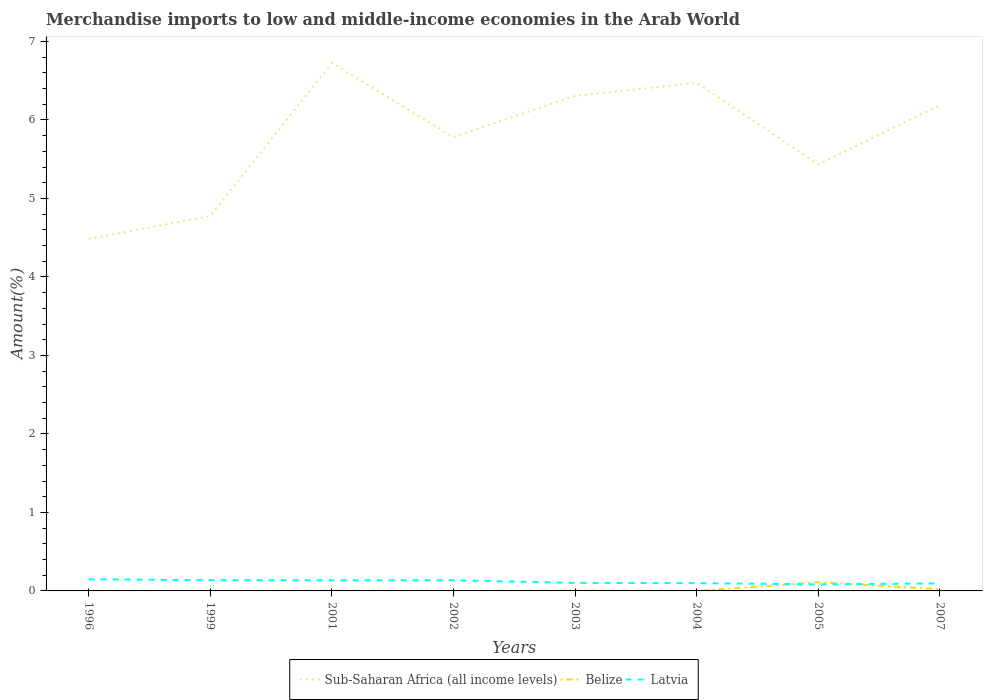How many different coloured lines are there?
Provide a short and direct response. 3. Does the line corresponding to Belize intersect with the line corresponding to Sub-Saharan Africa (all income levels)?
Ensure brevity in your answer.  No. Across all years, what is the maximum percentage of amount earned from merchandise imports in Sub-Saharan Africa (all income levels)?
Offer a very short reply. 4.48. What is the total percentage of amount earned from merchandise imports in Latvia in the graph?
Offer a very short reply. 0.02. What is the difference between the highest and the second highest percentage of amount earned from merchandise imports in Sub-Saharan Africa (all income levels)?
Keep it short and to the point. 2.24. What is the difference between the highest and the lowest percentage of amount earned from merchandise imports in Latvia?
Keep it short and to the point. 4. Is the percentage of amount earned from merchandise imports in Sub-Saharan Africa (all income levels) strictly greater than the percentage of amount earned from merchandise imports in Latvia over the years?
Your answer should be compact. No. What is the difference between two consecutive major ticks on the Y-axis?
Keep it short and to the point. 1. Are the values on the major ticks of Y-axis written in scientific E-notation?
Make the answer very short. No. Does the graph contain grids?
Make the answer very short. No. How many legend labels are there?
Offer a terse response. 3. What is the title of the graph?
Provide a succinct answer. Merchandise imports to low and middle-income economies in the Arab World. What is the label or title of the X-axis?
Give a very brief answer. Years. What is the label or title of the Y-axis?
Your response must be concise. Amount(%). What is the Amount(%) in Sub-Saharan Africa (all income levels) in 1996?
Ensure brevity in your answer.  4.48. What is the Amount(%) in Belize in 1996?
Provide a succinct answer. 0. What is the Amount(%) in Latvia in 1996?
Keep it short and to the point. 0.15. What is the Amount(%) of Sub-Saharan Africa (all income levels) in 1999?
Give a very brief answer. 4.78. What is the Amount(%) of Belize in 1999?
Ensure brevity in your answer.  0. What is the Amount(%) in Latvia in 1999?
Give a very brief answer. 0.14. What is the Amount(%) of Sub-Saharan Africa (all income levels) in 2001?
Your answer should be compact. 6.73. What is the Amount(%) in Belize in 2001?
Keep it short and to the point. 0. What is the Amount(%) in Latvia in 2001?
Your answer should be very brief. 0.13. What is the Amount(%) in Sub-Saharan Africa (all income levels) in 2002?
Offer a very short reply. 5.78. What is the Amount(%) in Belize in 2002?
Your response must be concise. 0. What is the Amount(%) of Latvia in 2002?
Your response must be concise. 0.14. What is the Amount(%) of Sub-Saharan Africa (all income levels) in 2003?
Offer a terse response. 6.31. What is the Amount(%) of Belize in 2003?
Offer a very short reply. 0. What is the Amount(%) in Latvia in 2003?
Ensure brevity in your answer.  0.1. What is the Amount(%) in Sub-Saharan Africa (all income levels) in 2004?
Ensure brevity in your answer.  6.47. What is the Amount(%) in Belize in 2004?
Keep it short and to the point. 0. What is the Amount(%) of Latvia in 2004?
Your answer should be compact. 0.1. What is the Amount(%) in Sub-Saharan Africa (all income levels) in 2005?
Give a very brief answer. 5.43. What is the Amount(%) of Belize in 2005?
Your answer should be very brief. 0.11. What is the Amount(%) of Latvia in 2005?
Provide a succinct answer. 0.08. What is the Amount(%) of Sub-Saharan Africa (all income levels) in 2007?
Your response must be concise. 6.19. What is the Amount(%) of Belize in 2007?
Provide a short and direct response. 0.02. What is the Amount(%) in Latvia in 2007?
Provide a short and direct response. 0.1. Across all years, what is the maximum Amount(%) in Sub-Saharan Africa (all income levels)?
Your answer should be very brief. 6.73. Across all years, what is the maximum Amount(%) of Belize?
Your answer should be compact. 0.11. Across all years, what is the maximum Amount(%) in Latvia?
Provide a short and direct response. 0.15. Across all years, what is the minimum Amount(%) in Sub-Saharan Africa (all income levels)?
Your response must be concise. 4.48. Across all years, what is the minimum Amount(%) of Belize?
Ensure brevity in your answer.  0. Across all years, what is the minimum Amount(%) of Latvia?
Provide a succinct answer. 0.08. What is the total Amount(%) in Sub-Saharan Africa (all income levels) in the graph?
Your answer should be very brief. 46.17. What is the total Amount(%) of Belize in the graph?
Your response must be concise. 0.14. What is the total Amount(%) of Latvia in the graph?
Make the answer very short. 0.94. What is the difference between the Amount(%) in Sub-Saharan Africa (all income levels) in 1996 and that in 1999?
Your answer should be very brief. -0.29. What is the difference between the Amount(%) in Belize in 1996 and that in 1999?
Keep it short and to the point. 0. What is the difference between the Amount(%) in Latvia in 1996 and that in 1999?
Make the answer very short. 0.01. What is the difference between the Amount(%) in Sub-Saharan Africa (all income levels) in 1996 and that in 2001?
Offer a terse response. -2.24. What is the difference between the Amount(%) in Belize in 1996 and that in 2001?
Your answer should be compact. -0. What is the difference between the Amount(%) in Latvia in 1996 and that in 2001?
Provide a short and direct response. 0.01. What is the difference between the Amount(%) in Sub-Saharan Africa (all income levels) in 1996 and that in 2002?
Provide a short and direct response. -1.3. What is the difference between the Amount(%) in Latvia in 1996 and that in 2002?
Offer a terse response. 0.01. What is the difference between the Amount(%) in Sub-Saharan Africa (all income levels) in 1996 and that in 2003?
Your answer should be compact. -1.82. What is the difference between the Amount(%) in Belize in 1996 and that in 2003?
Give a very brief answer. -0. What is the difference between the Amount(%) in Latvia in 1996 and that in 2003?
Your response must be concise. 0.05. What is the difference between the Amount(%) in Sub-Saharan Africa (all income levels) in 1996 and that in 2004?
Offer a very short reply. -1.99. What is the difference between the Amount(%) in Belize in 1996 and that in 2004?
Your answer should be very brief. 0. What is the difference between the Amount(%) of Latvia in 1996 and that in 2004?
Your response must be concise. 0.05. What is the difference between the Amount(%) in Sub-Saharan Africa (all income levels) in 1996 and that in 2005?
Give a very brief answer. -0.95. What is the difference between the Amount(%) in Belize in 1996 and that in 2005?
Ensure brevity in your answer.  -0.11. What is the difference between the Amount(%) in Latvia in 1996 and that in 2005?
Give a very brief answer. 0.07. What is the difference between the Amount(%) in Sub-Saharan Africa (all income levels) in 1996 and that in 2007?
Ensure brevity in your answer.  -1.71. What is the difference between the Amount(%) of Belize in 1996 and that in 2007?
Your answer should be compact. -0.02. What is the difference between the Amount(%) in Latvia in 1996 and that in 2007?
Ensure brevity in your answer.  0.05. What is the difference between the Amount(%) of Sub-Saharan Africa (all income levels) in 1999 and that in 2001?
Ensure brevity in your answer.  -1.95. What is the difference between the Amount(%) in Belize in 1999 and that in 2001?
Give a very brief answer. -0. What is the difference between the Amount(%) of Latvia in 1999 and that in 2001?
Your answer should be compact. 0. What is the difference between the Amount(%) in Sub-Saharan Africa (all income levels) in 1999 and that in 2002?
Offer a very short reply. -1. What is the difference between the Amount(%) of Belize in 1999 and that in 2002?
Your answer should be compact. 0. What is the difference between the Amount(%) of Latvia in 1999 and that in 2002?
Your answer should be very brief. 0. What is the difference between the Amount(%) in Sub-Saharan Africa (all income levels) in 1999 and that in 2003?
Keep it short and to the point. -1.53. What is the difference between the Amount(%) of Belize in 1999 and that in 2003?
Give a very brief answer. -0. What is the difference between the Amount(%) in Latvia in 1999 and that in 2003?
Provide a succinct answer. 0.04. What is the difference between the Amount(%) in Sub-Saharan Africa (all income levels) in 1999 and that in 2004?
Offer a terse response. -1.7. What is the difference between the Amount(%) of Latvia in 1999 and that in 2004?
Your response must be concise. 0.04. What is the difference between the Amount(%) in Sub-Saharan Africa (all income levels) in 1999 and that in 2005?
Ensure brevity in your answer.  -0.66. What is the difference between the Amount(%) in Belize in 1999 and that in 2005?
Give a very brief answer. -0.11. What is the difference between the Amount(%) in Latvia in 1999 and that in 2005?
Your answer should be compact. 0.05. What is the difference between the Amount(%) of Sub-Saharan Africa (all income levels) in 1999 and that in 2007?
Give a very brief answer. -1.41. What is the difference between the Amount(%) of Belize in 1999 and that in 2007?
Your response must be concise. -0.02. What is the difference between the Amount(%) in Latvia in 1999 and that in 2007?
Provide a succinct answer. 0.04. What is the difference between the Amount(%) in Sub-Saharan Africa (all income levels) in 2001 and that in 2002?
Make the answer very short. 0.95. What is the difference between the Amount(%) in Belize in 2001 and that in 2002?
Your answer should be compact. 0. What is the difference between the Amount(%) in Latvia in 2001 and that in 2002?
Your answer should be very brief. -0. What is the difference between the Amount(%) of Sub-Saharan Africa (all income levels) in 2001 and that in 2003?
Your answer should be very brief. 0.42. What is the difference between the Amount(%) in Belize in 2001 and that in 2003?
Your answer should be compact. -0. What is the difference between the Amount(%) of Latvia in 2001 and that in 2003?
Provide a succinct answer. 0.03. What is the difference between the Amount(%) of Sub-Saharan Africa (all income levels) in 2001 and that in 2004?
Your answer should be very brief. 0.25. What is the difference between the Amount(%) in Belize in 2001 and that in 2004?
Give a very brief answer. 0. What is the difference between the Amount(%) in Latvia in 2001 and that in 2004?
Offer a very short reply. 0.04. What is the difference between the Amount(%) of Sub-Saharan Africa (all income levels) in 2001 and that in 2005?
Offer a terse response. 1.29. What is the difference between the Amount(%) of Belize in 2001 and that in 2005?
Provide a short and direct response. -0.11. What is the difference between the Amount(%) of Latvia in 2001 and that in 2005?
Keep it short and to the point. 0.05. What is the difference between the Amount(%) of Sub-Saharan Africa (all income levels) in 2001 and that in 2007?
Your answer should be compact. 0.54. What is the difference between the Amount(%) of Belize in 2001 and that in 2007?
Your answer should be compact. -0.02. What is the difference between the Amount(%) in Latvia in 2001 and that in 2007?
Ensure brevity in your answer.  0.04. What is the difference between the Amount(%) of Sub-Saharan Africa (all income levels) in 2002 and that in 2003?
Your answer should be compact. -0.53. What is the difference between the Amount(%) in Belize in 2002 and that in 2003?
Give a very brief answer. -0. What is the difference between the Amount(%) of Latvia in 2002 and that in 2003?
Offer a very short reply. 0.03. What is the difference between the Amount(%) in Sub-Saharan Africa (all income levels) in 2002 and that in 2004?
Your answer should be very brief. -0.69. What is the difference between the Amount(%) of Belize in 2002 and that in 2004?
Keep it short and to the point. -0. What is the difference between the Amount(%) in Latvia in 2002 and that in 2004?
Keep it short and to the point. 0.04. What is the difference between the Amount(%) of Sub-Saharan Africa (all income levels) in 2002 and that in 2005?
Keep it short and to the point. 0.35. What is the difference between the Amount(%) of Belize in 2002 and that in 2005?
Offer a terse response. -0.11. What is the difference between the Amount(%) of Latvia in 2002 and that in 2005?
Your answer should be compact. 0.05. What is the difference between the Amount(%) of Sub-Saharan Africa (all income levels) in 2002 and that in 2007?
Make the answer very short. -0.41. What is the difference between the Amount(%) in Belize in 2002 and that in 2007?
Ensure brevity in your answer.  -0.02. What is the difference between the Amount(%) of Latvia in 2002 and that in 2007?
Ensure brevity in your answer.  0.04. What is the difference between the Amount(%) in Sub-Saharan Africa (all income levels) in 2003 and that in 2004?
Provide a short and direct response. -0.17. What is the difference between the Amount(%) in Belize in 2003 and that in 2004?
Your answer should be compact. 0. What is the difference between the Amount(%) in Latvia in 2003 and that in 2004?
Offer a very short reply. 0. What is the difference between the Amount(%) of Sub-Saharan Africa (all income levels) in 2003 and that in 2005?
Keep it short and to the point. 0.87. What is the difference between the Amount(%) in Belize in 2003 and that in 2005?
Give a very brief answer. -0.11. What is the difference between the Amount(%) of Latvia in 2003 and that in 2005?
Provide a succinct answer. 0.02. What is the difference between the Amount(%) in Sub-Saharan Africa (all income levels) in 2003 and that in 2007?
Keep it short and to the point. 0.12. What is the difference between the Amount(%) in Belize in 2003 and that in 2007?
Provide a short and direct response. -0.02. What is the difference between the Amount(%) of Latvia in 2003 and that in 2007?
Your answer should be compact. 0.01. What is the difference between the Amount(%) in Sub-Saharan Africa (all income levels) in 2004 and that in 2005?
Your answer should be very brief. 1.04. What is the difference between the Amount(%) of Belize in 2004 and that in 2005?
Offer a very short reply. -0.11. What is the difference between the Amount(%) in Latvia in 2004 and that in 2005?
Make the answer very short. 0.02. What is the difference between the Amount(%) of Sub-Saharan Africa (all income levels) in 2004 and that in 2007?
Provide a short and direct response. 0.28. What is the difference between the Amount(%) in Belize in 2004 and that in 2007?
Your answer should be very brief. -0.02. What is the difference between the Amount(%) in Latvia in 2004 and that in 2007?
Your answer should be very brief. 0. What is the difference between the Amount(%) of Sub-Saharan Africa (all income levels) in 2005 and that in 2007?
Ensure brevity in your answer.  -0.76. What is the difference between the Amount(%) of Belize in 2005 and that in 2007?
Your answer should be very brief. 0.09. What is the difference between the Amount(%) in Latvia in 2005 and that in 2007?
Offer a terse response. -0.01. What is the difference between the Amount(%) in Sub-Saharan Africa (all income levels) in 1996 and the Amount(%) in Belize in 1999?
Your answer should be very brief. 4.48. What is the difference between the Amount(%) of Sub-Saharan Africa (all income levels) in 1996 and the Amount(%) of Latvia in 1999?
Give a very brief answer. 4.35. What is the difference between the Amount(%) of Belize in 1996 and the Amount(%) of Latvia in 1999?
Provide a short and direct response. -0.14. What is the difference between the Amount(%) in Sub-Saharan Africa (all income levels) in 1996 and the Amount(%) in Belize in 2001?
Your response must be concise. 4.48. What is the difference between the Amount(%) in Sub-Saharan Africa (all income levels) in 1996 and the Amount(%) in Latvia in 2001?
Your answer should be very brief. 4.35. What is the difference between the Amount(%) of Belize in 1996 and the Amount(%) of Latvia in 2001?
Make the answer very short. -0.13. What is the difference between the Amount(%) of Sub-Saharan Africa (all income levels) in 1996 and the Amount(%) of Belize in 2002?
Ensure brevity in your answer.  4.48. What is the difference between the Amount(%) in Sub-Saharan Africa (all income levels) in 1996 and the Amount(%) in Latvia in 2002?
Give a very brief answer. 4.35. What is the difference between the Amount(%) in Belize in 1996 and the Amount(%) in Latvia in 2002?
Offer a terse response. -0.13. What is the difference between the Amount(%) in Sub-Saharan Africa (all income levels) in 1996 and the Amount(%) in Belize in 2003?
Your answer should be very brief. 4.48. What is the difference between the Amount(%) in Sub-Saharan Africa (all income levels) in 1996 and the Amount(%) in Latvia in 2003?
Provide a succinct answer. 4.38. What is the difference between the Amount(%) of Belize in 1996 and the Amount(%) of Latvia in 2003?
Provide a succinct answer. -0.1. What is the difference between the Amount(%) in Sub-Saharan Africa (all income levels) in 1996 and the Amount(%) in Belize in 2004?
Provide a short and direct response. 4.48. What is the difference between the Amount(%) of Sub-Saharan Africa (all income levels) in 1996 and the Amount(%) of Latvia in 2004?
Your answer should be compact. 4.39. What is the difference between the Amount(%) of Belize in 1996 and the Amount(%) of Latvia in 2004?
Your answer should be very brief. -0.1. What is the difference between the Amount(%) of Sub-Saharan Africa (all income levels) in 1996 and the Amount(%) of Belize in 2005?
Your response must be concise. 4.37. What is the difference between the Amount(%) of Sub-Saharan Africa (all income levels) in 1996 and the Amount(%) of Latvia in 2005?
Your answer should be compact. 4.4. What is the difference between the Amount(%) of Belize in 1996 and the Amount(%) of Latvia in 2005?
Offer a terse response. -0.08. What is the difference between the Amount(%) in Sub-Saharan Africa (all income levels) in 1996 and the Amount(%) in Belize in 2007?
Provide a succinct answer. 4.46. What is the difference between the Amount(%) in Sub-Saharan Africa (all income levels) in 1996 and the Amount(%) in Latvia in 2007?
Provide a succinct answer. 4.39. What is the difference between the Amount(%) of Belize in 1996 and the Amount(%) of Latvia in 2007?
Offer a terse response. -0.1. What is the difference between the Amount(%) in Sub-Saharan Africa (all income levels) in 1999 and the Amount(%) in Belize in 2001?
Ensure brevity in your answer.  4.77. What is the difference between the Amount(%) of Sub-Saharan Africa (all income levels) in 1999 and the Amount(%) of Latvia in 2001?
Provide a succinct answer. 4.64. What is the difference between the Amount(%) of Belize in 1999 and the Amount(%) of Latvia in 2001?
Provide a short and direct response. -0.13. What is the difference between the Amount(%) of Sub-Saharan Africa (all income levels) in 1999 and the Amount(%) of Belize in 2002?
Your response must be concise. 4.78. What is the difference between the Amount(%) in Sub-Saharan Africa (all income levels) in 1999 and the Amount(%) in Latvia in 2002?
Offer a very short reply. 4.64. What is the difference between the Amount(%) in Belize in 1999 and the Amount(%) in Latvia in 2002?
Your answer should be very brief. -0.14. What is the difference between the Amount(%) in Sub-Saharan Africa (all income levels) in 1999 and the Amount(%) in Belize in 2003?
Keep it short and to the point. 4.77. What is the difference between the Amount(%) of Sub-Saharan Africa (all income levels) in 1999 and the Amount(%) of Latvia in 2003?
Your answer should be compact. 4.67. What is the difference between the Amount(%) in Belize in 1999 and the Amount(%) in Latvia in 2003?
Ensure brevity in your answer.  -0.1. What is the difference between the Amount(%) of Sub-Saharan Africa (all income levels) in 1999 and the Amount(%) of Belize in 2004?
Your response must be concise. 4.78. What is the difference between the Amount(%) in Sub-Saharan Africa (all income levels) in 1999 and the Amount(%) in Latvia in 2004?
Ensure brevity in your answer.  4.68. What is the difference between the Amount(%) of Belize in 1999 and the Amount(%) of Latvia in 2004?
Provide a succinct answer. -0.1. What is the difference between the Amount(%) of Sub-Saharan Africa (all income levels) in 1999 and the Amount(%) of Belize in 2005?
Offer a very short reply. 4.67. What is the difference between the Amount(%) in Sub-Saharan Africa (all income levels) in 1999 and the Amount(%) in Latvia in 2005?
Keep it short and to the point. 4.69. What is the difference between the Amount(%) in Belize in 1999 and the Amount(%) in Latvia in 2005?
Your response must be concise. -0.08. What is the difference between the Amount(%) of Sub-Saharan Africa (all income levels) in 1999 and the Amount(%) of Belize in 2007?
Give a very brief answer. 4.75. What is the difference between the Amount(%) of Sub-Saharan Africa (all income levels) in 1999 and the Amount(%) of Latvia in 2007?
Provide a succinct answer. 4.68. What is the difference between the Amount(%) in Belize in 1999 and the Amount(%) in Latvia in 2007?
Ensure brevity in your answer.  -0.1. What is the difference between the Amount(%) in Sub-Saharan Africa (all income levels) in 2001 and the Amount(%) in Belize in 2002?
Your answer should be compact. 6.73. What is the difference between the Amount(%) in Sub-Saharan Africa (all income levels) in 2001 and the Amount(%) in Latvia in 2002?
Offer a terse response. 6.59. What is the difference between the Amount(%) in Belize in 2001 and the Amount(%) in Latvia in 2002?
Provide a short and direct response. -0.13. What is the difference between the Amount(%) in Sub-Saharan Africa (all income levels) in 2001 and the Amount(%) in Belize in 2003?
Provide a succinct answer. 6.72. What is the difference between the Amount(%) of Sub-Saharan Africa (all income levels) in 2001 and the Amount(%) of Latvia in 2003?
Give a very brief answer. 6.62. What is the difference between the Amount(%) of Belize in 2001 and the Amount(%) of Latvia in 2003?
Ensure brevity in your answer.  -0.1. What is the difference between the Amount(%) of Sub-Saharan Africa (all income levels) in 2001 and the Amount(%) of Belize in 2004?
Provide a short and direct response. 6.73. What is the difference between the Amount(%) of Sub-Saharan Africa (all income levels) in 2001 and the Amount(%) of Latvia in 2004?
Provide a succinct answer. 6.63. What is the difference between the Amount(%) of Belize in 2001 and the Amount(%) of Latvia in 2004?
Your answer should be very brief. -0.1. What is the difference between the Amount(%) in Sub-Saharan Africa (all income levels) in 2001 and the Amount(%) in Belize in 2005?
Provide a short and direct response. 6.62. What is the difference between the Amount(%) in Sub-Saharan Africa (all income levels) in 2001 and the Amount(%) in Latvia in 2005?
Make the answer very short. 6.64. What is the difference between the Amount(%) of Belize in 2001 and the Amount(%) of Latvia in 2005?
Offer a very short reply. -0.08. What is the difference between the Amount(%) of Sub-Saharan Africa (all income levels) in 2001 and the Amount(%) of Belize in 2007?
Make the answer very short. 6.7. What is the difference between the Amount(%) in Sub-Saharan Africa (all income levels) in 2001 and the Amount(%) in Latvia in 2007?
Make the answer very short. 6.63. What is the difference between the Amount(%) of Belize in 2001 and the Amount(%) of Latvia in 2007?
Offer a terse response. -0.09. What is the difference between the Amount(%) in Sub-Saharan Africa (all income levels) in 2002 and the Amount(%) in Belize in 2003?
Give a very brief answer. 5.78. What is the difference between the Amount(%) in Sub-Saharan Africa (all income levels) in 2002 and the Amount(%) in Latvia in 2003?
Provide a succinct answer. 5.68. What is the difference between the Amount(%) of Belize in 2002 and the Amount(%) of Latvia in 2003?
Keep it short and to the point. -0.1. What is the difference between the Amount(%) in Sub-Saharan Africa (all income levels) in 2002 and the Amount(%) in Belize in 2004?
Offer a very short reply. 5.78. What is the difference between the Amount(%) in Sub-Saharan Africa (all income levels) in 2002 and the Amount(%) in Latvia in 2004?
Ensure brevity in your answer.  5.68. What is the difference between the Amount(%) of Belize in 2002 and the Amount(%) of Latvia in 2004?
Give a very brief answer. -0.1. What is the difference between the Amount(%) of Sub-Saharan Africa (all income levels) in 2002 and the Amount(%) of Belize in 2005?
Provide a short and direct response. 5.67. What is the difference between the Amount(%) of Sub-Saharan Africa (all income levels) in 2002 and the Amount(%) of Latvia in 2005?
Provide a short and direct response. 5.7. What is the difference between the Amount(%) in Belize in 2002 and the Amount(%) in Latvia in 2005?
Your answer should be compact. -0.08. What is the difference between the Amount(%) in Sub-Saharan Africa (all income levels) in 2002 and the Amount(%) in Belize in 2007?
Make the answer very short. 5.76. What is the difference between the Amount(%) in Sub-Saharan Africa (all income levels) in 2002 and the Amount(%) in Latvia in 2007?
Make the answer very short. 5.68. What is the difference between the Amount(%) in Belize in 2002 and the Amount(%) in Latvia in 2007?
Provide a short and direct response. -0.1. What is the difference between the Amount(%) in Sub-Saharan Africa (all income levels) in 2003 and the Amount(%) in Belize in 2004?
Provide a short and direct response. 6.31. What is the difference between the Amount(%) in Sub-Saharan Africa (all income levels) in 2003 and the Amount(%) in Latvia in 2004?
Provide a short and direct response. 6.21. What is the difference between the Amount(%) in Belize in 2003 and the Amount(%) in Latvia in 2004?
Give a very brief answer. -0.1. What is the difference between the Amount(%) of Sub-Saharan Africa (all income levels) in 2003 and the Amount(%) of Belize in 2005?
Your answer should be very brief. 6.2. What is the difference between the Amount(%) in Sub-Saharan Africa (all income levels) in 2003 and the Amount(%) in Latvia in 2005?
Offer a very short reply. 6.23. What is the difference between the Amount(%) of Belize in 2003 and the Amount(%) of Latvia in 2005?
Keep it short and to the point. -0.08. What is the difference between the Amount(%) of Sub-Saharan Africa (all income levels) in 2003 and the Amount(%) of Belize in 2007?
Provide a succinct answer. 6.29. What is the difference between the Amount(%) of Sub-Saharan Africa (all income levels) in 2003 and the Amount(%) of Latvia in 2007?
Provide a short and direct response. 6.21. What is the difference between the Amount(%) in Belize in 2003 and the Amount(%) in Latvia in 2007?
Offer a very short reply. -0.09. What is the difference between the Amount(%) in Sub-Saharan Africa (all income levels) in 2004 and the Amount(%) in Belize in 2005?
Make the answer very short. 6.36. What is the difference between the Amount(%) in Sub-Saharan Africa (all income levels) in 2004 and the Amount(%) in Latvia in 2005?
Offer a very short reply. 6.39. What is the difference between the Amount(%) of Belize in 2004 and the Amount(%) of Latvia in 2005?
Your response must be concise. -0.08. What is the difference between the Amount(%) of Sub-Saharan Africa (all income levels) in 2004 and the Amount(%) of Belize in 2007?
Your response must be concise. 6.45. What is the difference between the Amount(%) of Sub-Saharan Africa (all income levels) in 2004 and the Amount(%) of Latvia in 2007?
Ensure brevity in your answer.  6.38. What is the difference between the Amount(%) in Belize in 2004 and the Amount(%) in Latvia in 2007?
Your answer should be compact. -0.1. What is the difference between the Amount(%) in Sub-Saharan Africa (all income levels) in 2005 and the Amount(%) in Belize in 2007?
Keep it short and to the point. 5.41. What is the difference between the Amount(%) in Sub-Saharan Africa (all income levels) in 2005 and the Amount(%) in Latvia in 2007?
Provide a short and direct response. 5.34. What is the difference between the Amount(%) in Belize in 2005 and the Amount(%) in Latvia in 2007?
Provide a succinct answer. 0.01. What is the average Amount(%) in Sub-Saharan Africa (all income levels) per year?
Your answer should be very brief. 5.77. What is the average Amount(%) of Belize per year?
Your answer should be compact. 0.02. What is the average Amount(%) of Latvia per year?
Give a very brief answer. 0.12. In the year 1996, what is the difference between the Amount(%) in Sub-Saharan Africa (all income levels) and Amount(%) in Belize?
Give a very brief answer. 4.48. In the year 1996, what is the difference between the Amount(%) of Sub-Saharan Africa (all income levels) and Amount(%) of Latvia?
Offer a very short reply. 4.34. In the year 1996, what is the difference between the Amount(%) in Belize and Amount(%) in Latvia?
Offer a terse response. -0.15. In the year 1999, what is the difference between the Amount(%) in Sub-Saharan Africa (all income levels) and Amount(%) in Belize?
Offer a very short reply. 4.78. In the year 1999, what is the difference between the Amount(%) of Sub-Saharan Africa (all income levels) and Amount(%) of Latvia?
Offer a very short reply. 4.64. In the year 1999, what is the difference between the Amount(%) of Belize and Amount(%) of Latvia?
Ensure brevity in your answer.  -0.14. In the year 2001, what is the difference between the Amount(%) in Sub-Saharan Africa (all income levels) and Amount(%) in Belize?
Make the answer very short. 6.72. In the year 2001, what is the difference between the Amount(%) of Sub-Saharan Africa (all income levels) and Amount(%) of Latvia?
Ensure brevity in your answer.  6.59. In the year 2001, what is the difference between the Amount(%) in Belize and Amount(%) in Latvia?
Offer a terse response. -0.13. In the year 2002, what is the difference between the Amount(%) in Sub-Saharan Africa (all income levels) and Amount(%) in Belize?
Your answer should be very brief. 5.78. In the year 2002, what is the difference between the Amount(%) in Sub-Saharan Africa (all income levels) and Amount(%) in Latvia?
Make the answer very short. 5.65. In the year 2002, what is the difference between the Amount(%) in Belize and Amount(%) in Latvia?
Provide a succinct answer. -0.14. In the year 2003, what is the difference between the Amount(%) of Sub-Saharan Africa (all income levels) and Amount(%) of Belize?
Provide a short and direct response. 6.3. In the year 2003, what is the difference between the Amount(%) in Sub-Saharan Africa (all income levels) and Amount(%) in Latvia?
Make the answer very short. 6.21. In the year 2003, what is the difference between the Amount(%) of Belize and Amount(%) of Latvia?
Ensure brevity in your answer.  -0.1. In the year 2004, what is the difference between the Amount(%) in Sub-Saharan Africa (all income levels) and Amount(%) in Belize?
Provide a short and direct response. 6.47. In the year 2004, what is the difference between the Amount(%) of Sub-Saharan Africa (all income levels) and Amount(%) of Latvia?
Give a very brief answer. 6.37. In the year 2004, what is the difference between the Amount(%) in Belize and Amount(%) in Latvia?
Offer a very short reply. -0.1. In the year 2005, what is the difference between the Amount(%) in Sub-Saharan Africa (all income levels) and Amount(%) in Belize?
Your answer should be very brief. 5.32. In the year 2005, what is the difference between the Amount(%) in Sub-Saharan Africa (all income levels) and Amount(%) in Latvia?
Provide a succinct answer. 5.35. In the year 2005, what is the difference between the Amount(%) in Belize and Amount(%) in Latvia?
Your response must be concise. 0.03. In the year 2007, what is the difference between the Amount(%) of Sub-Saharan Africa (all income levels) and Amount(%) of Belize?
Give a very brief answer. 6.17. In the year 2007, what is the difference between the Amount(%) of Sub-Saharan Africa (all income levels) and Amount(%) of Latvia?
Your response must be concise. 6.09. In the year 2007, what is the difference between the Amount(%) of Belize and Amount(%) of Latvia?
Provide a short and direct response. -0.07. What is the ratio of the Amount(%) in Sub-Saharan Africa (all income levels) in 1996 to that in 1999?
Give a very brief answer. 0.94. What is the ratio of the Amount(%) of Belize in 1996 to that in 1999?
Give a very brief answer. 4.3. What is the ratio of the Amount(%) of Latvia in 1996 to that in 1999?
Provide a succinct answer. 1.09. What is the ratio of the Amount(%) in Sub-Saharan Africa (all income levels) in 1996 to that in 2001?
Your answer should be compact. 0.67. What is the ratio of the Amount(%) in Belize in 1996 to that in 2001?
Your response must be concise. 0.71. What is the ratio of the Amount(%) in Latvia in 1996 to that in 2001?
Your answer should be compact. 1.11. What is the ratio of the Amount(%) of Sub-Saharan Africa (all income levels) in 1996 to that in 2002?
Your response must be concise. 0.78. What is the ratio of the Amount(%) in Belize in 1996 to that in 2002?
Give a very brief answer. 9.07. What is the ratio of the Amount(%) of Latvia in 1996 to that in 2002?
Offer a terse response. 1.1. What is the ratio of the Amount(%) of Sub-Saharan Africa (all income levels) in 1996 to that in 2003?
Give a very brief answer. 0.71. What is the ratio of the Amount(%) of Belize in 1996 to that in 2003?
Your answer should be compact. 0.29. What is the ratio of the Amount(%) of Latvia in 1996 to that in 2003?
Offer a terse response. 1.46. What is the ratio of the Amount(%) in Sub-Saharan Africa (all income levels) in 1996 to that in 2004?
Provide a succinct answer. 0.69. What is the ratio of the Amount(%) of Belize in 1996 to that in 2004?
Your answer should be very brief. 6.05. What is the ratio of the Amount(%) in Latvia in 1996 to that in 2004?
Ensure brevity in your answer.  1.5. What is the ratio of the Amount(%) in Sub-Saharan Africa (all income levels) in 1996 to that in 2005?
Offer a very short reply. 0.83. What is the ratio of the Amount(%) in Belize in 1996 to that in 2005?
Offer a terse response. 0.01. What is the ratio of the Amount(%) of Latvia in 1996 to that in 2005?
Ensure brevity in your answer.  1.8. What is the ratio of the Amount(%) in Sub-Saharan Africa (all income levels) in 1996 to that in 2007?
Provide a succinct answer. 0.72. What is the ratio of the Amount(%) in Belize in 1996 to that in 2007?
Make the answer very short. 0.05. What is the ratio of the Amount(%) of Latvia in 1996 to that in 2007?
Ensure brevity in your answer.  1.55. What is the ratio of the Amount(%) in Sub-Saharan Africa (all income levels) in 1999 to that in 2001?
Offer a very short reply. 0.71. What is the ratio of the Amount(%) of Belize in 1999 to that in 2001?
Your answer should be very brief. 0.17. What is the ratio of the Amount(%) of Latvia in 1999 to that in 2001?
Offer a terse response. 1.02. What is the ratio of the Amount(%) of Sub-Saharan Africa (all income levels) in 1999 to that in 2002?
Make the answer very short. 0.83. What is the ratio of the Amount(%) in Belize in 1999 to that in 2002?
Your response must be concise. 2.11. What is the ratio of the Amount(%) of Latvia in 1999 to that in 2002?
Your answer should be compact. 1.01. What is the ratio of the Amount(%) of Sub-Saharan Africa (all income levels) in 1999 to that in 2003?
Offer a terse response. 0.76. What is the ratio of the Amount(%) of Belize in 1999 to that in 2003?
Your answer should be very brief. 0.07. What is the ratio of the Amount(%) of Latvia in 1999 to that in 2003?
Keep it short and to the point. 1.34. What is the ratio of the Amount(%) in Sub-Saharan Africa (all income levels) in 1999 to that in 2004?
Give a very brief answer. 0.74. What is the ratio of the Amount(%) of Belize in 1999 to that in 2004?
Your response must be concise. 1.41. What is the ratio of the Amount(%) in Latvia in 1999 to that in 2004?
Offer a very short reply. 1.38. What is the ratio of the Amount(%) of Sub-Saharan Africa (all income levels) in 1999 to that in 2005?
Your answer should be compact. 0.88. What is the ratio of the Amount(%) of Belize in 1999 to that in 2005?
Your response must be concise. 0. What is the ratio of the Amount(%) in Latvia in 1999 to that in 2005?
Offer a terse response. 1.66. What is the ratio of the Amount(%) of Sub-Saharan Africa (all income levels) in 1999 to that in 2007?
Provide a short and direct response. 0.77. What is the ratio of the Amount(%) in Belize in 1999 to that in 2007?
Make the answer very short. 0.01. What is the ratio of the Amount(%) of Latvia in 1999 to that in 2007?
Offer a very short reply. 1.42. What is the ratio of the Amount(%) in Sub-Saharan Africa (all income levels) in 2001 to that in 2002?
Your answer should be compact. 1.16. What is the ratio of the Amount(%) in Belize in 2001 to that in 2002?
Offer a very short reply. 12.69. What is the ratio of the Amount(%) of Latvia in 2001 to that in 2002?
Offer a very short reply. 0.99. What is the ratio of the Amount(%) in Sub-Saharan Africa (all income levels) in 2001 to that in 2003?
Your answer should be very brief. 1.07. What is the ratio of the Amount(%) in Belize in 2001 to that in 2003?
Your answer should be compact. 0.4. What is the ratio of the Amount(%) of Latvia in 2001 to that in 2003?
Keep it short and to the point. 1.32. What is the ratio of the Amount(%) of Sub-Saharan Africa (all income levels) in 2001 to that in 2004?
Provide a succinct answer. 1.04. What is the ratio of the Amount(%) of Belize in 2001 to that in 2004?
Ensure brevity in your answer.  8.46. What is the ratio of the Amount(%) of Latvia in 2001 to that in 2004?
Offer a very short reply. 1.35. What is the ratio of the Amount(%) in Sub-Saharan Africa (all income levels) in 2001 to that in 2005?
Ensure brevity in your answer.  1.24. What is the ratio of the Amount(%) in Belize in 2001 to that in 2005?
Offer a very short reply. 0.01. What is the ratio of the Amount(%) in Latvia in 2001 to that in 2005?
Give a very brief answer. 1.63. What is the ratio of the Amount(%) in Sub-Saharan Africa (all income levels) in 2001 to that in 2007?
Give a very brief answer. 1.09. What is the ratio of the Amount(%) in Belize in 2001 to that in 2007?
Your answer should be very brief. 0.08. What is the ratio of the Amount(%) in Latvia in 2001 to that in 2007?
Your answer should be compact. 1.4. What is the ratio of the Amount(%) in Sub-Saharan Africa (all income levels) in 2002 to that in 2003?
Your response must be concise. 0.92. What is the ratio of the Amount(%) of Belize in 2002 to that in 2003?
Give a very brief answer. 0.03. What is the ratio of the Amount(%) of Latvia in 2002 to that in 2003?
Give a very brief answer. 1.33. What is the ratio of the Amount(%) in Sub-Saharan Africa (all income levels) in 2002 to that in 2004?
Your response must be concise. 0.89. What is the ratio of the Amount(%) in Belize in 2002 to that in 2004?
Your answer should be compact. 0.67. What is the ratio of the Amount(%) of Latvia in 2002 to that in 2004?
Offer a terse response. 1.36. What is the ratio of the Amount(%) of Sub-Saharan Africa (all income levels) in 2002 to that in 2005?
Your response must be concise. 1.06. What is the ratio of the Amount(%) in Belize in 2002 to that in 2005?
Offer a terse response. 0. What is the ratio of the Amount(%) in Latvia in 2002 to that in 2005?
Your answer should be very brief. 1.64. What is the ratio of the Amount(%) of Sub-Saharan Africa (all income levels) in 2002 to that in 2007?
Make the answer very short. 0.93. What is the ratio of the Amount(%) of Belize in 2002 to that in 2007?
Your response must be concise. 0.01. What is the ratio of the Amount(%) in Latvia in 2002 to that in 2007?
Provide a succinct answer. 1.41. What is the ratio of the Amount(%) in Sub-Saharan Africa (all income levels) in 2003 to that in 2004?
Your answer should be very brief. 0.97. What is the ratio of the Amount(%) of Belize in 2003 to that in 2004?
Keep it short and to the point. 21.12. What is the ratio of the Amount(%) of Latvia in 2003 to that in 2004?
Ensure brevity in your answer.  1.03. What is the ratio of the Amount(%) in Sub-Saharan Africa (all income levels) in 2003 to that in 2005?
Keep it short and to the point. 1.16. What is the ratio of the Amount(%) of Belize in 2003 to that in 2005?
Ensure brevity in your answer.  0.04. What is the ratio of the Amount(%) of Latvia in 2003 to that in 2005?
Your response must be concise. 1.24. What is the ratio of the Amount(%) of Sub-Saharan Africa (all income levels) in 2003 to that in 2007?
Offer a very short reply. 1.02. What is the ratio of the Amount(%) in Belize in 2003 to that in 2007?
Make the answer very short. 0.19. What is the ratio of the Amount(%) of Latvia in 2003 to that in 2007?
Offer a very short reply. 1.06. What is the ratio of the Amount(%) of Sub-Saharan Africa (all income levels) in 2004 to that in 2005?
Keep it short and to the point. 1.19. What is the ratio of the Amount(%) in Belize in 2004 to that in 2005?
Provide a succinct answer. 0. What is the ratio of the Amount(%) of Latvia in 2004 to that in 2005?
Make the answer very short. 1.2. What is the ratio of the Amount(%) in Sub-Saharan Africa (all income levels) in 2004 to that in 2007?
Give a very brief answer. 1.05. What is the ratio of the Amount(%) of Belize in 2004 to that in 2007?
Provide a succinct answer. 0.01. What is the ratio of the Amount(%) of Latvia in 2004 to that in 2007?
Provide a short and direct response. 1.03. What is the ratio of the Amount(%) in Sub-Saharan Africa (all income levels) in 2005 to that in 2007?
Your response must be concise. 0.88. What is the ratio of the Amount(%) of Belize in 2005 to that in 2007?
Offer a terse response. 5.1. What is the ratio of the Amount(%) in Latvia in 2005 to that in 2007?
Your answer should be compact. 0.86. What is the difference between the highest and the second highest Amount(%) of Sub-Saharan Africa (all income levels)?
Ensure brevity in your answer.  0.25. What is the difference between the highest and the second highest Amount(%) in Belize?
Your response must be concise. 0.09. What is the difference between the highest and the second highest Amount(%) in Latvia?
Provide a short and direct response. 0.01. What is the difference between the highest and the lowest Amount(%) of Sub-Saharan Africa (all income levels)?
Keep it short and to the point. 2.24. What is the difference between the highest and the lowest Amount(%) in Belize?
Make the answer very short. 0.11. What is the difference between the highest and the lowest Amount(%) in Latvia?
Make the answer very short. 0.07. 